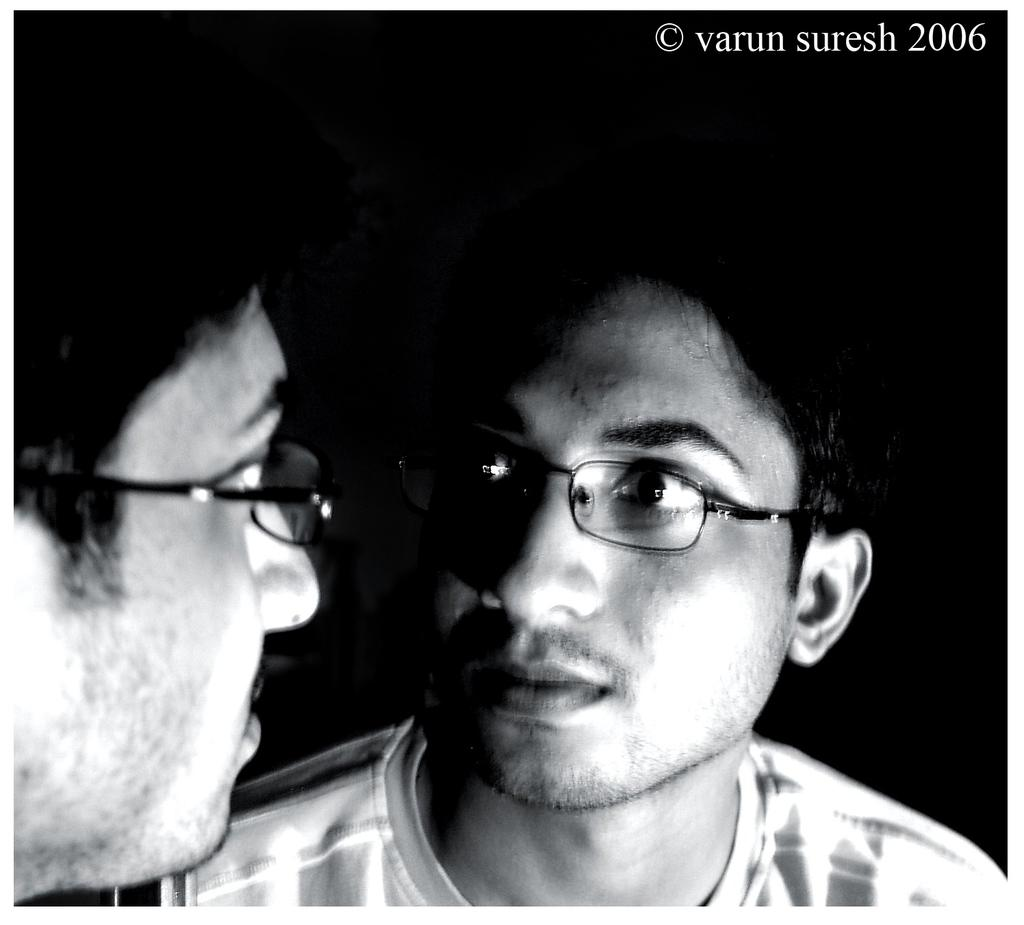What is the main subject of the image? There is a person in the image. Can you describe any additional details about the person? The person's reflection is visible in a mirror. What can be seen in the background of the image? The background of the image is completely dark. What type of bat can be seen flying in the image? There is no bat present in the image; it features a person and their reflection in a mirror against a dark background. 